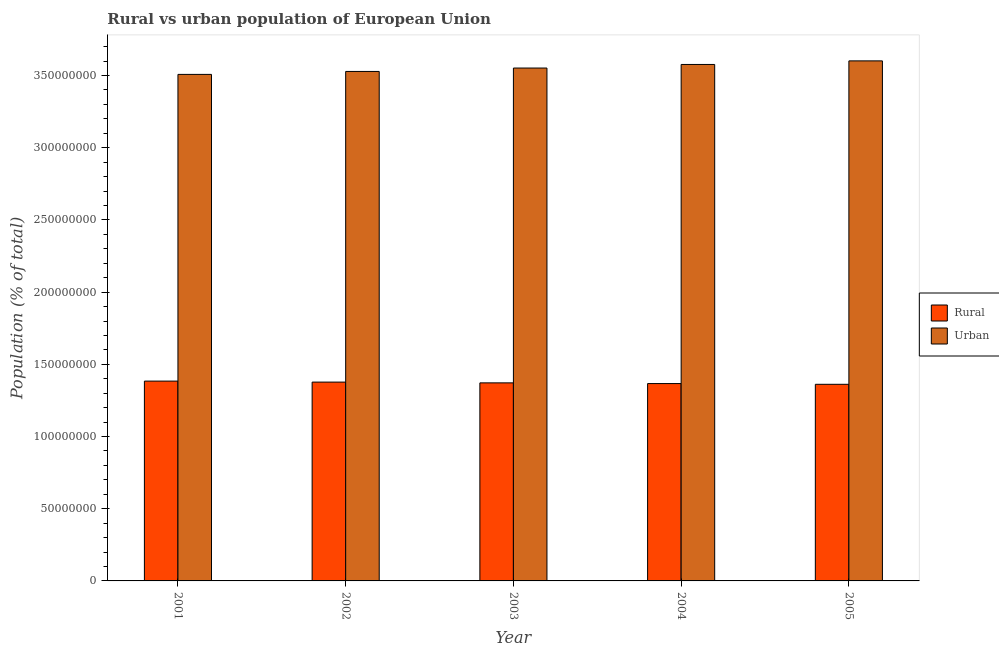Are the number of bars per tick equal to the number of legend labels?
Offer a terse response. Yes. Are the number of bars on each tick of the X-axis equal?
Your answer should be compact. Yes. How many bars are there on the 3rd tick from the right?
Give a very brief answer. 2. In how many cases, is the number of bars for a given year not equal to the number of legend labels?
Provide a short and direct response. 0. What is the rural population density in 2004?
Provide a short and direct response. 1.37e+08. Across all years, what is the maximum urban population density?
Make the answer very short. 3.60e+08. Across all years, what is the minimum urban population density?
Provide a short and direct response. 3.51e+08. In which year was the urban population density maximum?
Your answer should be very brief. 2005. In which year was the rural population density minimum?
Your response must be concise. 2005. What is the total rural population density in the graph?
Ensure brevity in your answer.  6.86e+08. What is the difference between the urban population density in 2003 and that in 2005?
Offer a terse response. -4.96e+06. What is the difference between the urban population density in 2003 and the rural population density in 2001?
Give a very brief answer. 4.41e+06. What is the average urban population density per year?
Provide a short and direct response. 3.55e+08. In how many years, is the rural population density greater than 320000000 %?
Offer a terse response. 0. What is the ratio of the rural population density in 2001 to that in 2005?
Offer a very short reply. 1.02. Is the urban population density in 2002 less than that in 2004?
Provide a short and direct response. Yes. Is the difference between the rural population density in 2004 and 2005 greater than the difference between the urban population density in 2004 and 2005?
Your response must be concise. No. What is the difference between the highest and the second highest urban population density?
Give a very brief answer. 2.49e+06. What is the difference between the highest and the lowest rural population density?
Your answer should be compact. 2.22e+06. In how many years, is the urban population density greater than the average urban population density taken over all years?
Offer a terse response. 2. What does the 2nd bar from the left in 2003 represents?
Ensure brevity in your answer.  Urban. What does the 2nd bar from the right in 2004 represents?
Your answer should be very brief. Rural. How many bars are there?
Offer a terse response. 10. What is the difference between two consecutive major ticks on the Y-axis?
Ensure brevity in your answer.  5.00e+07. Does the graph contain any zero values?
Ensure brevity in your answer.  No. Does the graph contain grids?
Provide a succinct answer. No. Where does the legend appear in the graph?
Make the answer very short. Center right. How are the legend labels stacked?
Offer a terse response. Vertical. What is the title of the graph?
Your response must be concise. Rural vs urban population of European Union. Does "State government" appear as one of the legend labels in the graph?
Your response must be concise. No. What is the label or title of the Y-axis?
Provide a succinct answer. Population (% of total). What is the Population (% of total) in Rural in 2001?
Your answer should be very brief. 1.38e+08. What is the Population (% of total) of Urban in 2001?
Give a very brief answer. 3.51e+08. What is the Population (% of total) of Rural in 2002?
Your answer should be compact. 1.38e+08. What is the Population (% of total) of Urban in 2002?
Ensure brevity in your answer.  3.53e+08. What is the Population (% of total) in Rural in 2003?
Ensure brevity in your answer.  1.37e+08. What is the Population (% of total) in Urban in 2003?
Ensure brevity in your answer.  3.55e+08. What is the Population (% of total) of Rural in 2004?
Offer a terse response. 1.37e+08. What is the Population (% of total) of Urban in 2004?
Provide a succinct answer. 3.58e+08. What is the Population (% of total) in Rural in 2005?
Provide a short and direct response. 1.36e+08. What is the Population (% of total) of Urban in 2005?
Your answer should be compact. 3.60e+08. Across all years, what is the maximum Population (% of total) in Rural?
Ensure brevity in your answer.  1.38e+08. Across all years, what is the maximum Population (% of total) in Urban?
Offer a terse response. 3.60e+08. Across all years, what is the minimum Population (% of total) of Rural?
Ensure brevity in your answer.  1.36e+08. Across all years, what is the minimum Population (% of total) in Urban?
Ensure brevity in your answer.  3.51e+08. What is the total Population (% of total) in Rural in the graph?
Give a very brief answer. 6.86e+08. What is the total Population (% of total) of Urban in the graph?
Provide a short and direct response. 1.78e+09. What is the difference between the Population (% of total) of Rural in 2001 and that in 2002?
Your answer should be compact. 6.97e+05. What is the difference between the Population (% of total) in Urban in 2001 and that in 2002?
Offer a terse response. -2.04e+06. What is the difference between the Population (% of total) of Rural in 2001 and that in 2003?
Your response must be concise. 1.23e+06. What is the difference between the Population (% of total) of Urban in 2001 and that in 2003?
Keep it short and to the point. -4.41e+06. What is the difference between the Population (% of total) of Rural in 2001 and that in 2004?
Provide a short and direct response. 1.71e+06. What is the difference between the Population (% of total) of Urban in 2001 and that in 2004?
Provide a short and direct response. -6.88e+06. What is the difference between the Population (% of total) in Rural in 2001 and that in 2005?
Provide a short and direct response. 2.22e+06. What is the difference between the Population (% of total) of Urban in 2001 and that in 2005?
Ensure brevity in your answer.  -9.36e+06. What is the difference between the Population (% of total) in Rural in 2002 and that in 2003?
Offer a terse response. 5.29e+05. What is the difference between the Population (% of total) in Urban in 2002 and that in 2003?
Make the answer very short. -2.37e+06. What is the difference between the Population (% of total) in Rural in 2002 and that in 2004?
Your answer should be very brief. 1.01e+06. What is the difference between the Population (% of total) in Urban in 2002 and that in 2004?
Your response must be concise. -4.84e+06. What is the difference between the Population (% of total) in Rural in 2002 and that in 2005?
Your response must be concise. 1.52e+06. What is the difference between the Population (% of total) in Urban in 2002 and that in 2005?
Ensure brevity in your answer.  -7.32e+06. What is the difference between the Population (% of total) in Rural in 2003 and that in 2004?
Provide a short and direct response. 4.82e+05. What is the difference between the Population (% of total) of Urban in 2003 and that in 2004?
Ensure brevity in your answer.  -2.47e+06. What is the difference between the Population (% of total) in Rural in 2003 and that in 2005?
Offer a very short reply. 9.94e+05. What is the difference between the Population (% of total) in Urban in 2003 and that in 2005?
Offer a terse response. -4.96e+06. What is the difference between the Population (% of total) in Rural in 2004 and that in 2005?
Offer a terse response. 5.12e+05. What is the difference between the Population (% of total) of Urban in 2004 and that in 2005?
Your answer should be very brief. -2.49e+06. What is the difference between the Population (% of total) of Rural in 2001 and the Population (% of total) of Urban in 2002?
Provide a succinct answer. -2.14e+08. What is the difference between the Population (% of total) of Rural in 2001 and the Population (% of total) of Urban in 2003?
Your answer should be compact. -2.17e+08. What is the difference between the Population (% of total) of Rural in 2001 and the Population (% of total) of Urban in 2004?
Provide a short and direct response. -2.19e+08. What is the difference between the Population (% of total) in Rural in 2001 and the Population (% of total) in Urban in 2005?
Your answer should be very brief. -2.22e+08. What is the difference between the Population (% of total) in Rural in 2002 and the Population (% of total) in Urban in 2003?
Offer a very short reply. -2.18e+08. What is the difference between the Population (% of total) of Rural in 2002 and the Population (% of total) of Urban in 2004?
Ensure brevity in your answer.  -2.20e+08. What is the difference between the Population (% of total) in Rural in 2002 and the Population (% of total) in Urban in 2005?
Keep it short and to the point. -2.22e+08. What is the difference between the Population (% of total) in Rural in 2003 and the Population (% of total) in Urban in 2004?
Your answer should be very brief. -2.21e+08. What is the difference between the Population (% of total) in Rural in 2003 and the Population (% of total) in Urban in 2005?
Your answer should be very brief. -2.23e+08. What is the difference between the Population (% of total) in Rural in 2004 and the Population (% of total) in Urban in 2005?
Your answer should be compact. -2.23e+08. What is the average Population (% of total) of Rural per year?
Ensure brevity in your answer.  1.37e+08. What is the average Population (% of total) of Urban per year?
Offer a terse response. 3.55e+08. In the year 2001, what is the difference between the Population (% of total) in Rural and Population (% of total) in Urban?
Offer a very short reply. -2.12e+08. In the year 2002, what is the difference between the Population (% of total) of Rural and Population (% of total) of Urban?
Give a very brief answer. -2.15e+08. In the year 2003, what is the difference between the Population (% of total) of Rural and Population (% of total) of Urban?
Offer a very short reply. -2.18e+08. In the year 2004, what is the difference between the Population (% of total) of Rural and Population (% of total) of Urban?
Ensure brevity in your answer.  -2.21e+08. In the year 2005, what is the difference between the Population (% of total) of Rural and Population (% of total) of Urban?
Provide a short and direct response. -2.24e+08. What is the ratio of the Population (% of total) of Rural in 2001 to that in 2002?
Make the answer very short. 1.01. What is the ratio of the Population (% of total) of Urban in 2001 to that in 2002?
Ensure brevity in your answer.  0.99. What is the ratio of the Population (% of total) in Rural in 2001 to that in 2003?
Provide a short and direct response. 1.01. What is the ratio of the Population (% of total) of Urban in 2001 to that in 2003?
Your answer should be very brief. 0.99. What is the ratio of the Population (% of total) in Rural in 2001 to that in 2004?
Ensure brevity in your answer.  1.01. What is the ratio of the Population (% of total) in Urban in 2001 to that in 2004?
Your answer should be compact. 0.98. What is the ratio of the Population (% of total) in Rural in 2001 to that in 2005?
Provide a succinct answer. 1.02. What is the ratio of the Population (% of total) of Rural in 2002 to that in 2003?
Your answer should be very brief. 1. What is the ratio of the Population (% of total) of Urban in 2002 to that in 2003?
Keep it short and to the point. 0.99. What is the ratio of the Population (% of total) of Rural in 2002 to that in 2004?
Keep it short and to the point. 1.01. What is the ratio of the Population (% of total) in Urban in 2002 to that in 2004?
Your answer should be very brief. 0.99. What is the ratio of the Population (% of total) in Rural in 2002 to that in 2005?
Offer a very short reply. 1.01. What is the ratio of the Population (% of total) in Urban in 2002 to that in 2005?
Your response must be concise. 0.98. What is the ratio of the Population (% of total) in Rural in 2003 to that in 2005?
Your answer should be very brief. 1.01. What is the ratio of the Population (% of total) of Urban in 2003 to that in 2005?
Offer a very short reply. 0.99. What is the difference between the highest and the second highest Population (% of total) in Rural?
Give a very brief answer. 6.97e+05. What is the difference between the highest and the second highest Population (% of total) of Urban?
Ensure brevity in your answer.  2.49e+06. What is the difference between the highest and the lowest Population (% of total) of Rural?
Offer a very short reply. 2.22e+06. What is the difference between the highest and the lowest Population (% of total) of Urban?
Provide a succinct answer. 9.36e+06. 